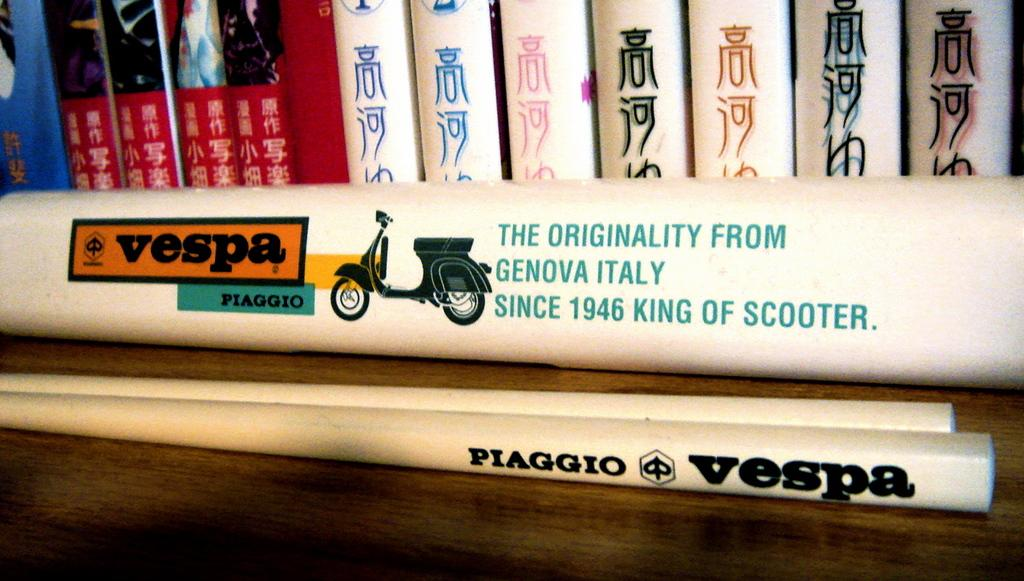<image>
Write a terse but informative summary of the picture. A couple of wooden sticks are labeled with Piaggio Vespa. 